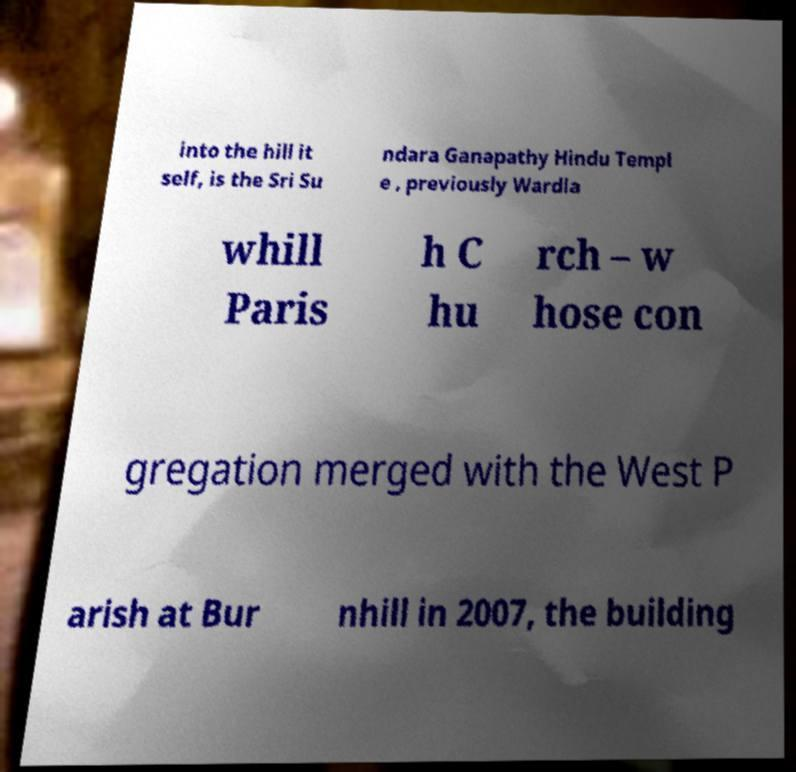For documentation purposes, I need the text within this image transcribed. Could you provide that? into the hill it self, is the Sri Su ndara Ganapathy Hindu Templ e , previously Wardla whill Paris h C hu rch – w hose con gregation merged with the West P arish at Bur nhill in 2007, the building 